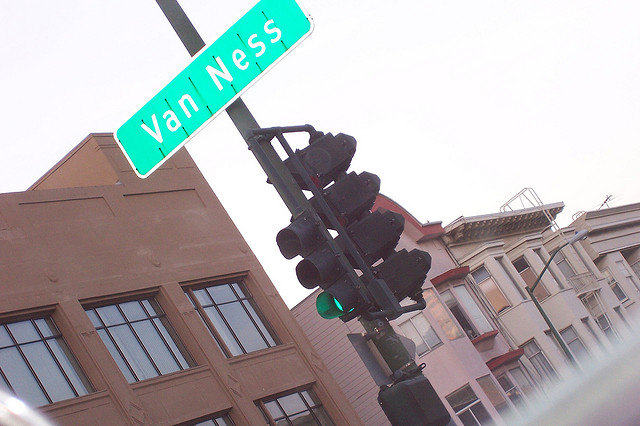Identify and read out the text in this image. Van Ness 